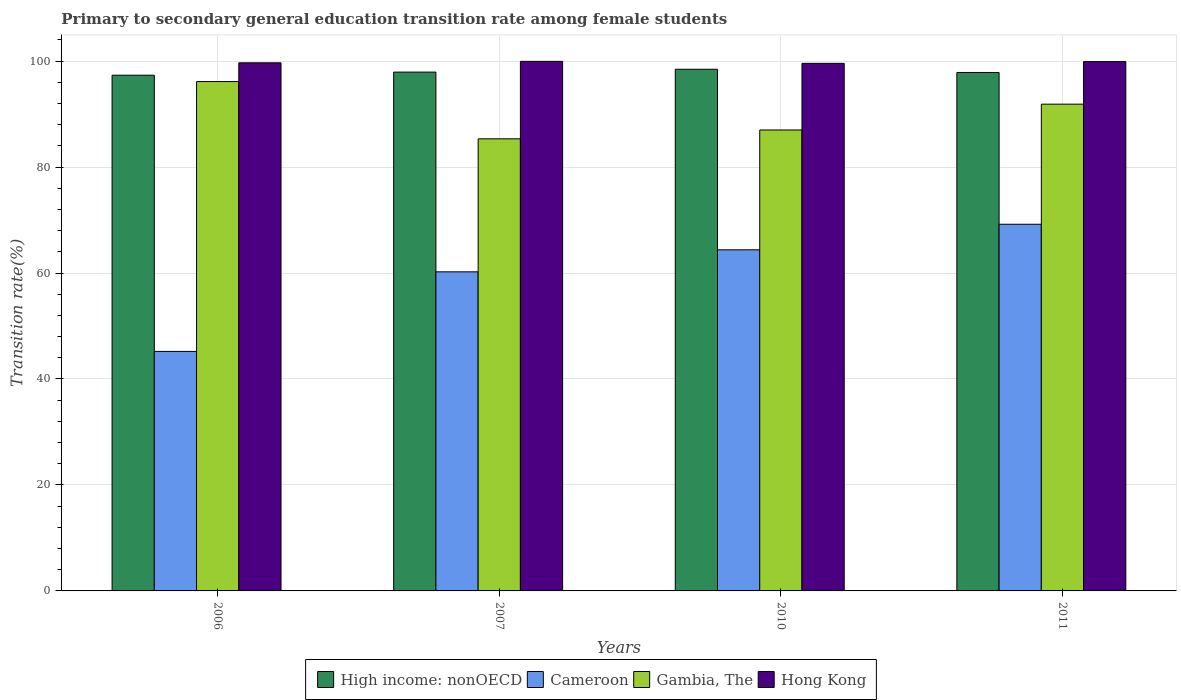How many different coloured bars are there?
Your response must be concise. 4. How many groups of bars are there?
Your answer should be very brief. 4. Are the number of bars per tick equal to the number of legend labels?
Your answer should be very brief. Yes. Are the number of bars on each tick of the X-axis equal?
Provide a succinct answer. Yes. How many bars are there on the 4th tick from the left?
Your answer should be very brief. 4. How many bars are there on the 2nd tick from the right?
Your answer should be compact. 4. What is the transition rate in High income: nonOECD in 2006?
Your answer should be compact. 97.33. Across all years, what is the maximum transition rate in Gambia, The?
Your answer should be compact. 96.13. Across all years, what is the minimum transition rate in High income: nonOECD?
Your answer should be compact. 97.33. In which year was the transition rate in High income: nonOECD maximum?
Make the answer very short. 2010. In which year was the transition rate in Hong Kong minimum?
Offer a very short reply. 2010. What is the total transition rate in High income: nonOECD in the graph?
Offer a very short reply. 391.55. What is the difference between the transition rate in High income: nonOECD in 2006 and that in 2010?
Your response must be concise. -1.12. What is the difference between the transition rate in Gambia, The in 2011 and the transition rate in Cameroon in 2006?
Your answer should be compact. 46.66. What is the average transition rate in Gambia, The per year?
Your response must be concise. 90.08. In the year 2010, what is the difference between the transition rate in Gambia, The and transition rate in Hong Kong?
Your response must be concise. -12.57. What is the ratio of the transition rate in High income: nonOECD in 2010 to that in 2011?
Provide a succinct answer. 1.01. Is the transition rate in Cameroon in 2007 less than that in 2011?
Give a very brief answer. Yes. Is the difference between the transition rate in Gambia, The in 2006 and 2010 greater than the difference between the transition rate in Hong Kong in 2006 and 2010?
Offer a very short reply. Yes. What is the difference between the highest and the second highest transition rate in Gambia, The?
Offer a terse response. 4.27. What is the difference between the highest and the lowest transition rate in Cameroon?
Make the answer very short. 24. Is the sum of the transition rate in High income: nonOECD in 2006 and 2010 greater than the maximum transition rate in Gambia, The across all years?
Your response must be concise. Yes. What does the 1st bar from the left in 2006 represents?
Offer a terse response. High income: nonOECD. What does the 4th bar from the right in 2011 represents?
Provide a succinct answer. High income: nonOECD. Are all the bars in the graph horizontal?
Make the answer very short. No. How many years are there in the graph?
Make the answer very short. 4. What is the difference between two consecutive major ticks on the Y-axis?
Your response must be concise. 20. Are the values on the major ticks of Y-axis written in scientific E-notation?
Keep it short and to the point. No. Does the graph contain any zero values?
Your response must be concise. No. Does the graph contain grids?
Offer a terse response. Yes. How many legend labels are there?
Give a very brief answer. 4. What is the title of the graph?
Offer a very short reply. Primary to secondary general education transition rate among female students. Does "Chad" appear as one of the legend labels in the graph?
Offer a very short reply. No. What is the label or title of the Y-axis?
Keep it short and to the point. Transition rate(%). What is the Transition rate(%) in High income: nonOECD in 2006?
Your response must be concise. 97.33. What is the Transition rate(%) of Cameroon in 2006?
Ensure brevity in your answer.  45.2. What is the Transition rate(%) in Gambia, The in 2006?
Your answer should be compact. 96.13. What is the Transition rate(%) of Hong Kong in 2006?
Your response must be concise. 99.67. What is the Transition rate(%) in High income: nonOECD in 2007?
Provide a short and direct response. 97.91. What is the Transition rate(%) of Cameroon in 2007?
Your answer should be very brief. 60.22. What is the Transition rate(%) in Gambia, The in 2007?
Provide a succinct answer. 85.32. What is the Transition rate(%) in Hong Kong in 2007?
Give a very brief answer. 99.94. What is the Transition rate(%) of High income: nonOECD in 2010?
Make the answer very short. 98.45. What is the Transition rate(%) of Cameroon in 2010?
Offer a very short reply. 64.38. What is the Transition rate(%) in Gambia, The in 2010?
Your answer should be compact. 86.99. What is the Transition rate(%) of Hong Kong in 2010?
Your response must be concise. 99.57. What is the Transition rate(%) in High income: nonOECD in 2011?
Your response must be concise. 97.84. What is the Transition rate(%) in Cameroon in 2011?
Offer a very short reply. 69.2. What is the Transition rate(%) of Gambia, The in 2011?
Offer a terse response. 91.86. What is the Transition rate(%) of Hong Kong in 2011?
Provide a short and direct response. 99.9. Across all years, what is the maximum Transition rate(%) in High income: nonOECD?
Offer a very short reply. 98.45. Across all years, what is the maximum Transition rate(%) in Cameroon?
Your answer should be very brief. 69.2. Across all years, what is the maximum Transition rate(%) of Gambia, The?
Your answer should be very brief. 96.13. Across all years, what is the maximum Transition rate(%) of Hong Kong?
Offer a very short reply. 99.94. Across all years, what is the minimum Transition rate(%) of High income: nonOECD?
Give a very brief answer. 97.33. Across all years, what is the minimum Transition rate(%) in Cameroon?
Offer a terse response. 45.2. Across all years, what is the minimum Transition rate(%) in Gambia, The?
Your answer should be compact. 85.32. Across all years, what is the minimum Transition rate(%) in Hong Kong?
Ensure brevity in your answer.  99.57. What is the total Transition rate(%) in High income: nonOECD in the graph?
Offer a very short reply. 391.55. What is the total Transition rate(%) of Cameroon in the graph?
Give a very brief answer. 239. What is the total Transition rate(%) in Gambia, The in the graph?
Ensure brevity in your answer.  360.31. What is the total Transition rate(%) in Hong Kong in the graph?
Offer a very short reply. 399.08. What is the difference between the Transition rate(%) in High income: nonOECD in 2006 and that in 2007?
Your response must be concise. -0.58. What is the difference between the Transition rate(%) of Cameroon in 2006 and that in 2007?
Offer a very short reply. -15.02. What is the difference between the Transition rate(%) in Gambia, The in 2006 and that in 2007?
Give a very brief answer. 10.81. What is the difference between the Transition rate(%) in Hong Kong in 2006 and that in 2007?
Offer a terse response. -0.28. What is the difference between the Transition rate(%) of High income: nonOECD in 2006 and that in 2010?
Keep it short and to the point. -1.12. What is the difference between the Transition rate(%) in Cameroon in 2006 and that in 2010?
Make the answer very short. -19.18. What is the difference between the Transition rate(%) in Gambia, The in 2006 and that in 2010?
Your response must be concise. 9.14. What is the difference between the Transition rate(%) of Hong Kong in 2006 and that in 2010?
Your answer should be compact. 0.1. What is the difference between the Transition rate(%) of High income: nonOECD in 2006 and that in 2011?
Offer a terse response. -0.51. What is the difference between the Transition rate(%) of Cameroon in 2006 and that in 2011?
Offer a very short reply. -24. What is the difference between the Transition rate(%) in Gambia, The in 2006 and that in 2011?
Ensure brevity in your answer.  4.27. What is the difference between the Transition rate(%) in Hong Kong in 2006 and that in 2011?
Your response must be concise. -0.24. What is the difference between the Transition rate(%) of High income: nonOECD in 2007 and that in 2010?
Offer a very short reply. -0.54. What is the difference between the Transition rate(%) of Cameroon in 2007 and that in 2010?
Your answer should be very brief. -4.16. What is the difference between the Transition rate(%) in Gambia, The in 2007 and that in 2010?
Ensure brevity in your answer.  -1.67. What is the difference between the Transition rate(%) of Hong Kong in 2007 and that in 2010?
Your answer should be compact. 0.38. What is the difference between the Transition rate(%) in High income: nonOECD in 2007 and that in 2011?
Provide a succinct answer. 0.07. What is the difference between the Transition rate(%) of Cameroon in 2007 and that in 2011?
Offer a very short reply. -8.98. What is the difference between the Transition rate(%) of Gambia, The in 2007 and that in 2011?
Offer a terse response. -6.54. What is the difference between the Transition rate(%) of Hong Kong in 2007 and that in 2011?
Offer a terse response. 0.04. What is the difference between the Transition rate(%) in High income: nonOECD in 2010 and that in 2011?
Offer a very short reply. 0.61. What is the difference between the Transition rate(%) in Cameroon in 2010 and that in 2011?
Offer a terse response. -4.82. What is the difference between the Transition rate(%) in Gambia, The in 2010 and that in 2011?
Offer a terse response. -4.87. What is the difference between the Transition rate(%) in Hong Kong in 2010 and that in 2011?
Give a very brief answer. -0.34. What is the difference between the Transition rate(%) in High income: nonOECD in 2006 and the Transition rate(%) in Cameroon in 2007?
Your response must be concise. 37.11. What is the difference between the Transition rate(%) in High income: nonOECD in 2006 and the Transition rate(%) in Gambia, The in 2007?
Provide a short and direct response. 12.01. What is the difference between the Transition rate(%) in High income: nonOECD in 2006 and the Transition rate(%) in Hong Kong in 2007?
Provide a short and direct response. -2.61. What is the difference between the Transition rate(%) in Cameroon in 2006 and the Transition rate(%) in Gambia, The in 2007?
Your answer should be very brief. -40.12. What is the difference between the Transition rate(%) of Cameroon in 2006 and the Transition rate(%) of Hong Kong in 2007?
Ensure brevity in your answer.  -54.74. What is the difference between the Transition rate(%) in Gambia, The in 2006 and the Transition rate(%) in Hong Kong in 2007?
Offer a very short reply. -3.81. What is the difference between the Transition rate(%) of High income: nonOECD in 2006 and the Transition rate(%) of Cameroon in 2010?
Your answer should be compact. 32.95. What is the difference between the Transition rate(%) of High income: nonOECD in 2006 and the Transition rate(%) of Gambia, The in 2010?
Offer a very short reply. 10.34. What is the difference between the Transition rate(%) in High income: nonOECD in 2006 and the Transition rate(%) in Hong Kong in 2010?
Make the answer very short. -2.23. What is the difference between the Transition rate(%) of Cameroon in 2006 and the Transition rate(%) of Gambia, The in 2010?
Offer a terse response. -41.79. What is the difference between the Transition rate(%) in Cameroon in 2006 and the Transition rate(%) in Hong Kong in 2010?
Keep it short and to the point. -54.36. What is the difference between the Transition rate(%) in Gambia, The in 2006 and the Transition rate(%) in Hong Kong in 2010?
Ensure brevity in your answer.  -3.43. What is the difference between the Transition rate(%) of High income: nonOECD in 2006 and the Transition rate(%) of Cameroon in 2011?
Your answer should be compact. 28.14. What is the difference between the Transition rate(%) in High income: nonOECD in 2006 and the Transition rate(%) in Gambia, The in 2011?
Your answer should be very brief. 5.47. What is the difference between the Transition rate(%) in High income: nonOECD in 2006 and the Transition rate(%) in Hong Kong in 2011?
Make the answer very short. -2.57. What is the difference between the Transition rate(%) in Cameroon in 2006 and the Transition rate(%) in Gambia, The in 2011?
Give a very brief answer. -46.66. What is the difference between the Transition rate(%) in Cameroon in 2006 and the Transition rate(%) in Hong Kong in 2011?
Keep it short and to the point. -54.7. What is the difference between the Transition rate(%) of Gambia, The in 2006 and the Transition rate(%) of Hong Kong in 2011?
Offer a terse response. -3.77. What is the difference between the Transition rate(%) in High income: nonOECD in 2007 and the Transition rate(%) in Cameroon in 2010?
Your answer should be very brief. 33.54. What is the difference between the Transition rate(%) in High income: nonOECD in 2007 and the Transition rate(%) in Gambia, The in 2010?
Give a very brief answer. 10.92. What is the difference between the Transition rate(%) in High income: nonOECD in 2007 and the Transition rate(%) in Hong Kong in 2010?
Keep it short and to the point. -1.65. What is the difference between the Transition rate(%) of Cameroon in 2007 and the Transition rate(%) of Gambia, The in 2010?
Make the answer very short. -26.77. What is the difference between the Transition rate(%) of Cameroon in 2007 and the Transition rate(%) of Hong Kong in 2010?
Keep it short and to the point. -39.35. What is the difference between the Transition rate(%) in Gambia, The in 2007 and the Transition rate(%) in Hong Kong in 2010?
Ensure brevity in your answer.  -14.24. What is the difference between the Transition rate(%) in High income: nonOECD in 2007 and the Transition rate(%) in Cameroon in 2011?
Your answer should be compact. 28.72. What is the difference between the Transition rate(%) of High income: nonOECD in 2007 and the Transition rate(%) of Gambia, The in 2011?
Your answer should be compact. 6.05. What is the difference between the Transition rate(%) in High income: nonOECD in 2007 and the Transition rate(%) in Hong Kong in 2011?
Keep it short and to the point. -1.99. What is the difference between the Transition rate(%) in Cameroon in 2007 and the Transition rate(%) in Gambia, The in 2011?
Offer a terse response. -31.65. What is the difference between the Transition rate(%) in Cameroon in 2007 and the Transition rate(%) in Hong Kong in 2011?
Keep it short and to the point. -39.69. What is the difference between the Transition rate(%) of Gambia, The in 2007 and the Transition rate(%) of Hong Kong in 2011?
Provide a succinct answer. -14.58. What is the difference between the Transition rate(%) in High income: nonOECD in 2010 and the Transition rate(%) in Cameroon in 2011?
Offer a terse response. 29.25. What is the difference between the Transition rate(%) of High income: nonOECD in 2010 and the Transition rate(%) of Gambia, The in 2011?
Your response must be concise. 6.59. What is the difference between the Transition rate(%) in High income: nonOECD in 2010 and the Transition rate(%) in Hong Kong in 2011?
Give a very brief answer. -1.45. What is the difference between the Transition rate(%) of Cameroon in 2010 and the Transition rate(%) of Gambia, The in 2011?
Your answer should be very brief. -27.49. What is the difference between the Transition rate(%) of Cameroon in 2010 and the Transition rate(%) of Hong Kong in 2011?
Keep it short and to the point. -35.53. What is the difference between the Transition rate(%) of Gambia, The in 2010 and the Transition rate(%) of Hong Kong in 2011?
Offer a terse response. -12.91. What is the average Transition rate(%) in High income: nonOECD per year?
Your response must be concise. 97.89. What is the average Transition rate(%) of Cameroon per year?
Your answer should be very brief. 59.75. What is the average Transition rate(%) in Gambia, The per year?
Offer a terse response. 90.08. What is the average Transition rate(%) in Hong Kong per year?
Offer a very short reply. 99.77. In the year 2006, what is the difference between the Transition rate(%) of High income: nonOECD and Transition rate(%) of Cameroon?
Keep it short and to the point. 52.13. In the year 2006, what is the difference between the Transition rate(%) of High income: nonOECD and Transition rate(%) of Gambia, The?
Provide a short and direct response. 1.2. In the year 2006, what is the difference between the Transition rate(%) in High income: nonOECD and Transition rate(%) in Hong Kong?
Keep it short and to the point. -2.33. In the year 2006, what is the difference between the Transition rate(%) of Cameroon and Transition rate(%) of Gambia, The?
Provide a succinct answer. -50.93. In the year 2006, what is the difference between the Transition rate(%) in Cameroon and Transition rate(%) in Hong Kong?
Your answer should be very brief. -54.47. In the year 2006, what is the difference between the Transition rate(%) in Gambia, The and Transition rate(%) in Hong Kong?
Provide a short and direct response. -3.53. In the year 2007, what is the difference between the Transition rate(%) of High income: nonOECD and Transition rate(%) of Cameroon?
Give a very brief answer. 37.7. In the year 2007, what is the difference between the Transition rate(%) of High income: nonOECD and Transition rate(%) of Gambia, The?
Provide a succinct answer. 12.59. In the year 2007, what is the difference between the Transition rate(%) in High income: nonOECD and Transition rate(%) in Hong Kong?
Ensure brevity in your answer.  -2.03. In the year 2007, what is the difference between the Transition rate(%) in Cameroon and Transition rate(%) in Gambia, The?
Keep it short and to the point. -25.1. In the year 2007, what is the difference between the Transition rate(%) of Cameroon and Transition rate(%) of Hong Kong?
Give a very brief answer. -39.73. In the year 2007, what is the difference between the Transition rate(%) in Gambia, The and Transition rate(%) in Hong Kong?
Ensure brevity in your answer.  -14.62. In the year 2010, what is the difference between the Transition rate(%) of High income: nonOECD and Transition rate(%) of Cameroon?
Your response must be concise. 34.07. In the year 2010, what is the difference between the Transition rate(%) in High income: nonOECD and Transition rate(%) in Gambia, The?
Ensure brevity in your answer.  11.46. In the year 2010, what is the difference between the Transition rate(%) of High income: nonOECD and Transition rate(%) of Hong Kong?
Your answer should be compact. -1.11. In the year 2010, what is the difference between the Transition rate(%) in Cameroon and Transition rate(%) in Gambia, The?
Give a very brief answer. -22.61. In the year 2010, what is the difference between the Transition rate(%) of Cameroon and Transition rate(%) of Hong Kong?
Offer a terse response. -35.19. In the year 2010, what is the difference between the Transition rate(%) of Gambia, The and Transition rate(%) of Hong Kong?
Your answer should be very brief. -12.57. In the year 2011, what is the difference between the Transition rate(%) of High income: nonOECD and Transition rate(%) of Cameroon?
Make the answer very short. 28.65. In the year 2011, what is the difference between the Transition rate(%) in High income: nonOECD and Transition rate(%) in Gambia, The?
Make the answer very short. 5.98. In the year 2011, what is the difference between the Transition rate(%) in High income: nonOECD and Transition rate(%) in Hong Kong?
Give a very brief answer. -2.06. In the year 2011, what is the difference between the Transition rate(%) in Cameroon and Transition rate(%) in Gambia, The?
Offer a very short reply. -22.67. In the year 2011, what is the difference between the Transition rate(%) in Cameroon and Transition rate(%) in Hong Kong?
Your answer should be compact. -30.71. In the year 2011, what is the difference between the Transition rate(%) of Gambia, The and Transition rate(%) of Hong Kong?
Provide a short and direct response. -8.04. What is the ratio of the Transition rate(%) of Cameroon in 2006 to that in 2007?
Keep it short and to the point. 0.75. What is the ratio of the Transition rate(%) of Gambia, The in 2006 to that in 2007?
Provide a succinct answer. 1.13. What is the ratio of the Transition rate(%) in Hong Kong in 2006 to that in 2007?
Your response must be concise. 1. What is the ratio of the Transition rate(%) of High income: nonOECD in 2006 to that in 2010?
Ensure brevity in your answer.  0.99. What is the ratio of the Transition rate(%) of Cameroon in 2006 to that in 2010?
Keep it short and to the point. 0.7. What is the ratio of the Transition rate(%) of Gambia, The in 2006 to that in 2010?
Your response must be concise. 1.11. What is the ratio of the Transition rate(%) of Hong Kong in 2006 to that in 2010?
Your response must be concise. 1. What is the ratio of the Transition rate(%) of High income: nonOECD in 2006 to that in 2011?
Make the answer very short. 0.99. What is the ratio of the Transition rate(%) in Cameroon in 2006 to that in 2011?
Provide a short and direct response. 0.65. What is the ratio of the Transition rate(%) in Gambia, The in 2006 to that in 2011?
Make the answer very short. 1.05. What is the ratio of the Transition rate(%) of High income: nonOECD in 2007 to that in 2010?
Keep it short and to the point. 0.99. What is the ratio of the Transition rate(%) of Cameroon in 2007 to that in 2010?
Your answer should be compact. 0.94. What is the ratio of the Transition rate(%) of Gambia, The in 2007 to that in 2010?
Offer a very short reply. 0.98. What is the ratio of the Transition rate(%) of Hong Kong in 2007 to that in 2010?
Keep it short and to the point. 1. What is the ratio of the Transition rate(%) in Cameroon in 2007 to that in 2011?
Your response must be concise. 0.87. What is the ratio of the Transition rate(%) of Gambia, The in 2007 to that in 2011?
Offer a terse response. 0.93. What is the ratio of the Transition rate(%) of Hong Kong in 2007 to that in 2011?
Ensure brevity in your answer.  1. What is the ratio of the Transition rate(%) in High income: nonOECD in 2010 to that in 2011?
Keep it short and to the point. 1.01. What is the ratio of the Transition rate(%) in Cameroon in 2010 to that in 2011?
Your answer should be very brief. 0.93. What is the ratio of the Transition rate(%) in Gambia, The in 2010 to that in 2011?
Ensure brevity in your answer.  0.95. What is the difference between the highest and the second highest Transition rate(%) in High income: nonOECD?
Give a very brief answer. 0.54. What is the difference between the highest and the second highest Transition rate(%) in Cameroon?
Offer a terse response. 4.82. What is the difference between the highest and the second highest Transition rate(%) in Gambia, The?
Ensure brevity in your answer.  4.27. What is the difference between the highest and the second highest Transition rate(%) of Hong Kong?
Your answer should be compact. 0.04. What is the difference between the highest and the lowest Transition rate(%) in High income: nonOECD?
Provide a succinct answer. 1.12. What is the difference between the highest and the lowest Transition rate(%) of Cameroon?
Give a very brief answer. 24. What is the difference between the highest and the lowest Transition rate(%) of Gambia, The?
Offer a terse response. 10.81. What is the difference between the highest and the lowest Transition rate(%) of Hong Kong?
Make the answer very short. 0.38. 